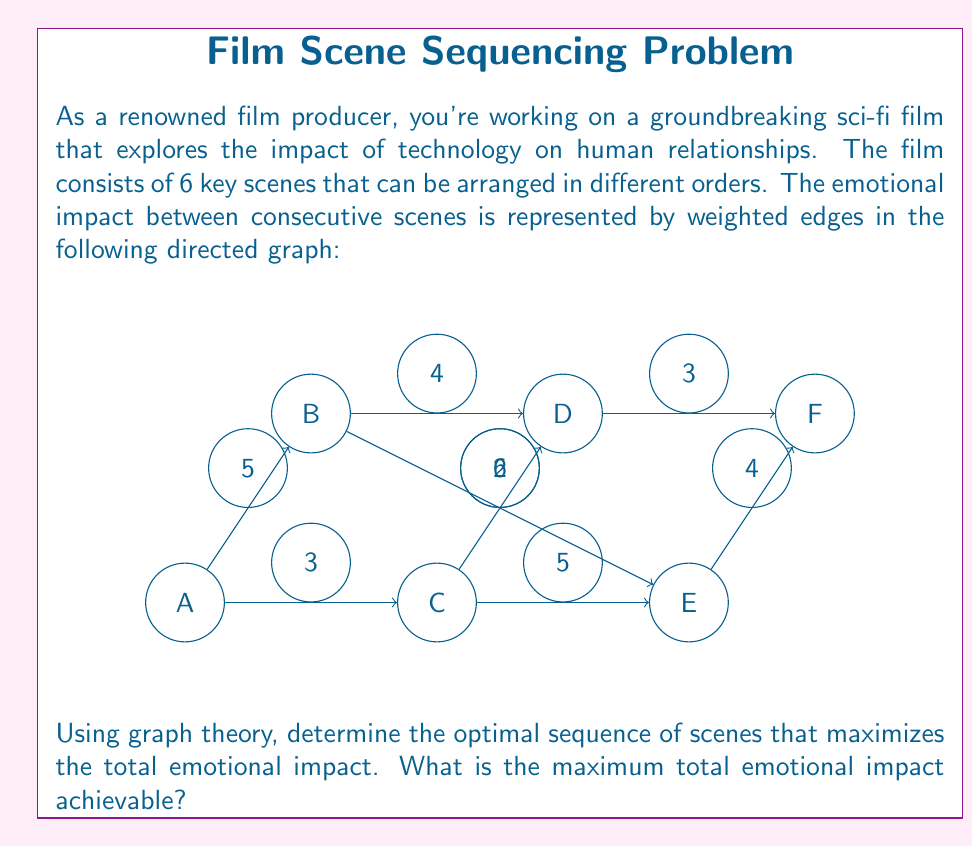Show me your answer to this math problem. To solve this problem, we can use the concept of finding the longest path in a directed acyclic graph (DAG). This is equivalent to finding the path with the maximum total weight.

Step 1: Identify the topological order of the nodes.
The topological order is already given: A, B, C, D, E, F.

Step 2: Initialize distances.
Let $d[v]$ represent the maximum distance to node $v$.
$d[A] = 0$, $d[B] = d[C] = d[D] = d[E] = d[F] = -\infty$

Step 3: Process nodes in topological order and update distances.

For A:
$d[B] = \max(d[B], d[A] + 5) = 5$
$d[C] = \max(d[C], d[A] + 3) = 3$

For B:
$d[D] = \max(d[D], d[B] + 4) = 9$
$d[E] = \max(d[E], d[B] + 2) = 7$

For C:
$d[D] = \max(d[D], d[C] + 6) = 9$
$d[E] = \max(d[E], d[C] + 5) = 8$

For D:
$d[F] = \max(d[F], d[D] + 3) = 12$

For E:
$d[F] = \max(d[F], d[E] + 4) = 12$

Step 4: The maximum total emotional impact is the maximum value in $d[F]$, which is 12.

Step 5: To find the optimal sequence, we backtrack from F:
F <- D (since 12 - 3 = 9, which is d[D])
D <- B (since 9 - 4 = 5, which is d[B])
B <- A (since 5 - 5 = 0, which is d[A])

Therefore, the optimal sequence is A -> B -> D -> F.
Answer: 12 (sequence: A -> B -> D -> F) 